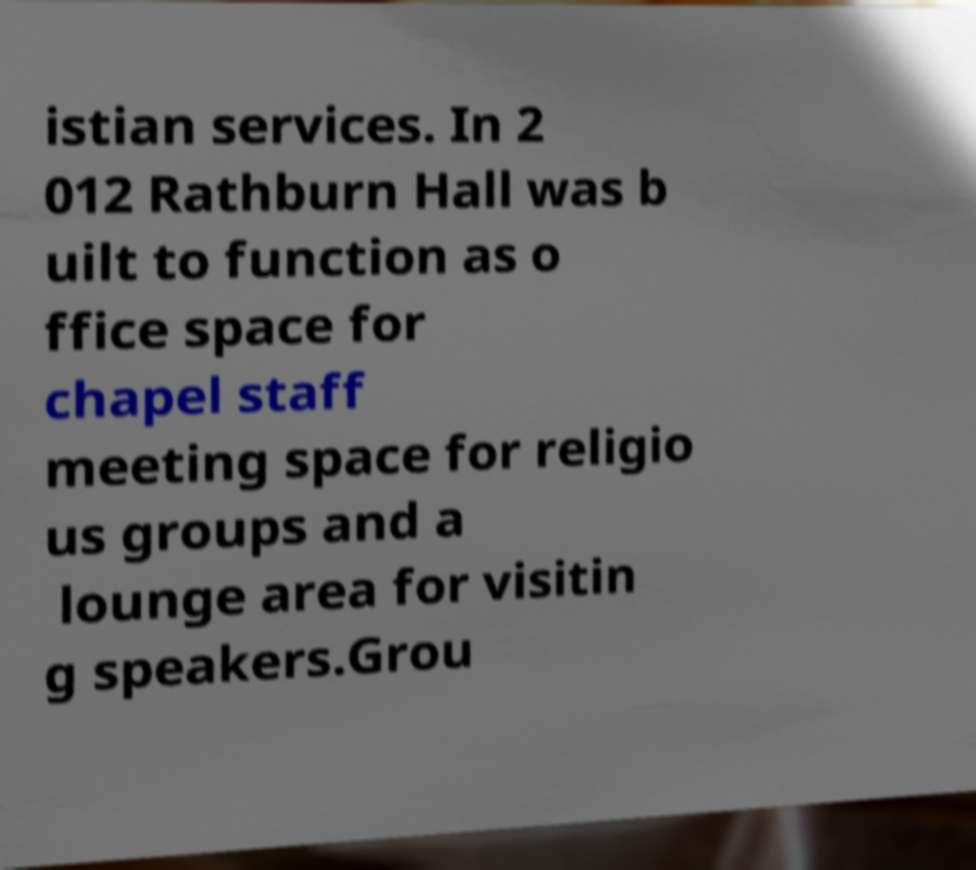Could you assist in decoding the text presented in this image and type it out clearly? istian services. In 2 012 Rathburn Hall was b uilt to function as o ffice space for chapel staff meeting space for religio us groups and a lounge area for visitin g speakers.Grou 